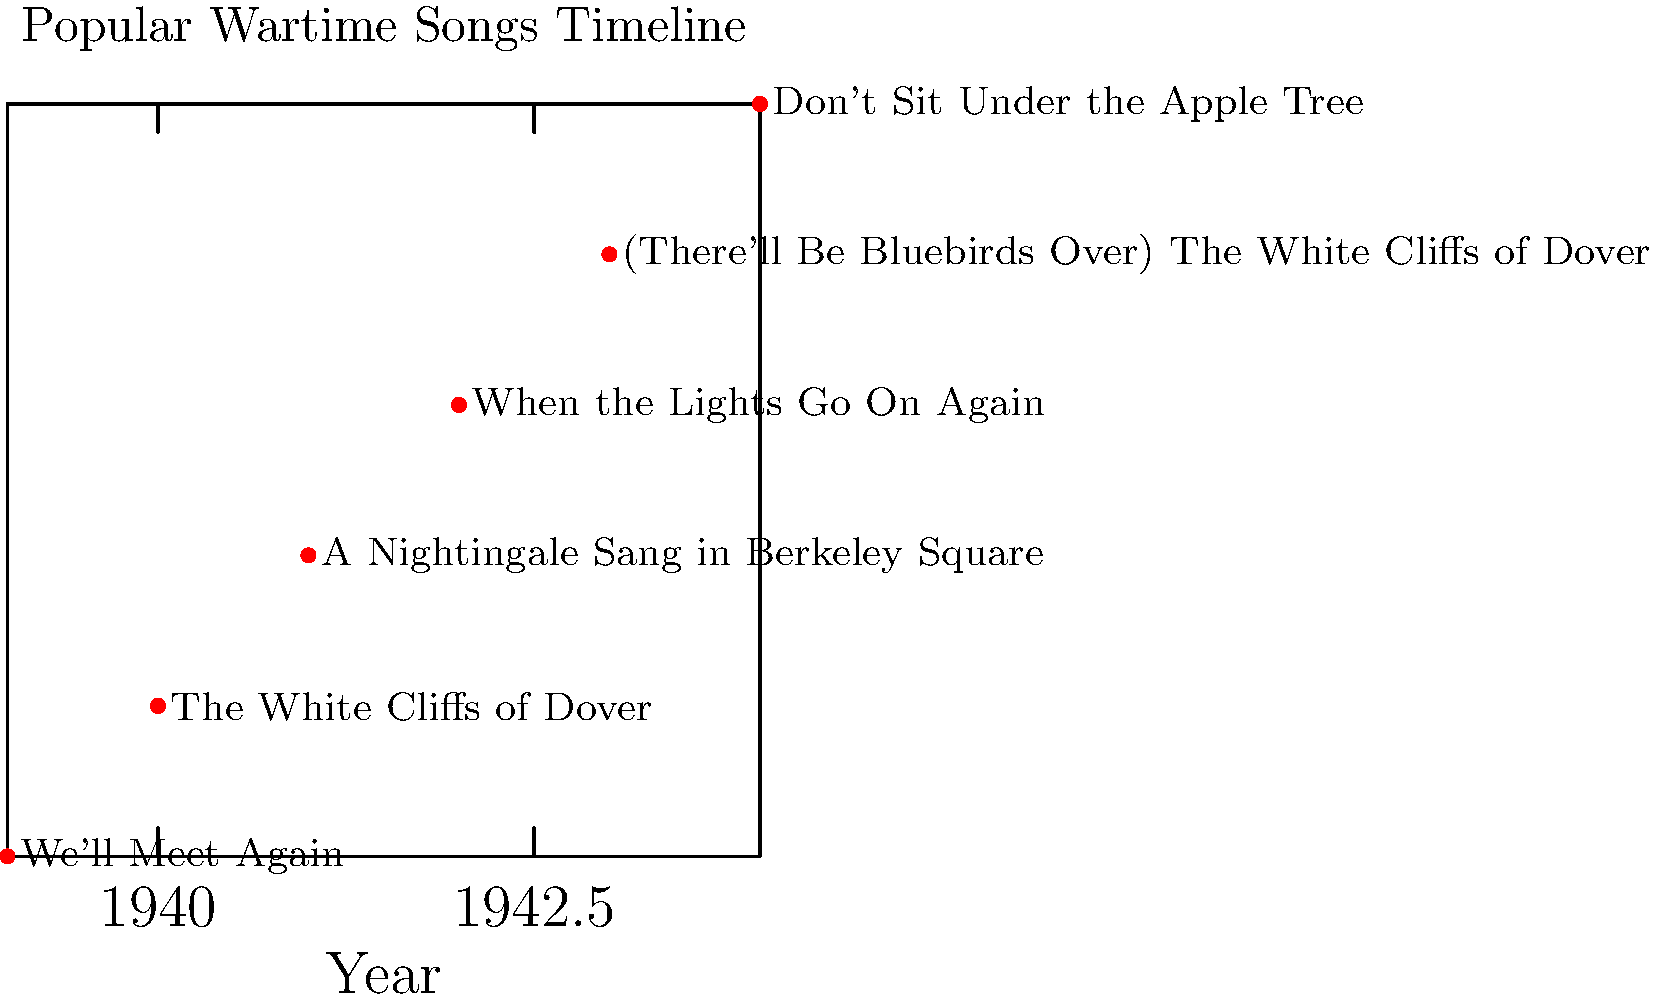Based on the timeline chart, which popular wartime song was released earliest, and in what year? To determine the earliest released song and its year, we need to follow these steps:

1. Examine the x-axis, which represents the years from 1939 to 1944.
2. Look at the leftmost point on the timeline, as this represents the earliest year.
3. Identify the song associated with this point.

Following these steps:

1. The x-axis shows years from 1939 to 1944.
2. The leftmost point on the timeline corresponds to the year 1939.
3. The song associated with this point is "We'll Meet Again".

Therefore, the earliest released song on this timeline is "We'll Meet Again" in 1939.
Answer: "We'll Meet Again" (1939) 